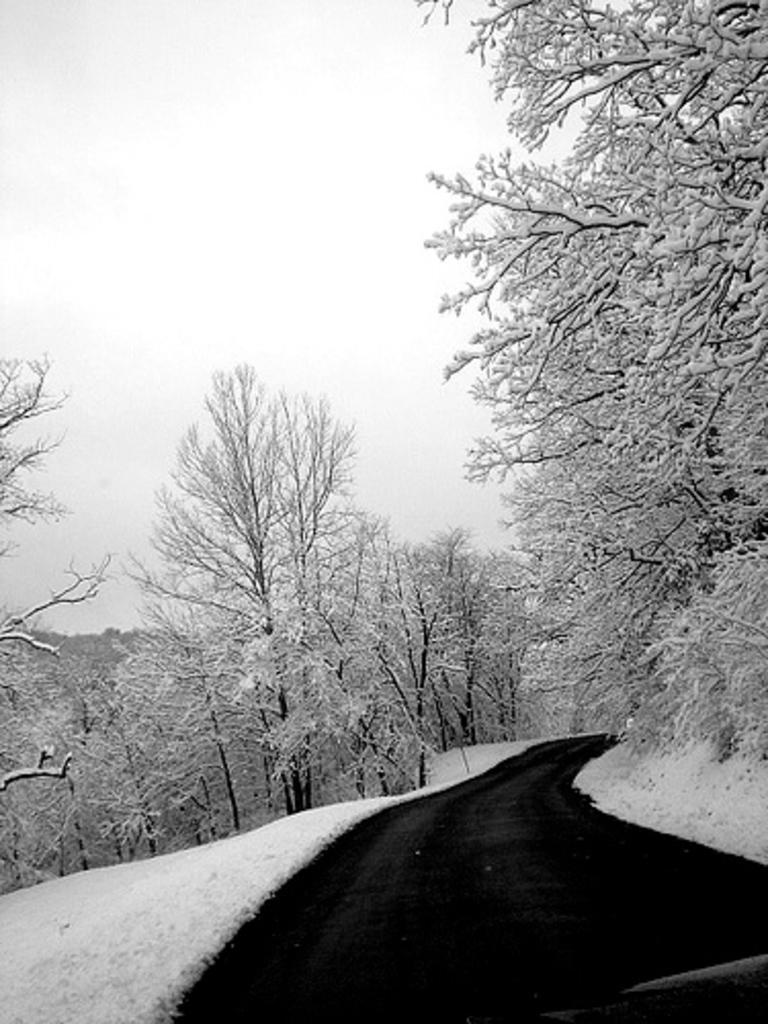Can you describe this image briefly? In this image we can see the trees and in between the trees we can see the road and snow. In the background, we can see the sky. 